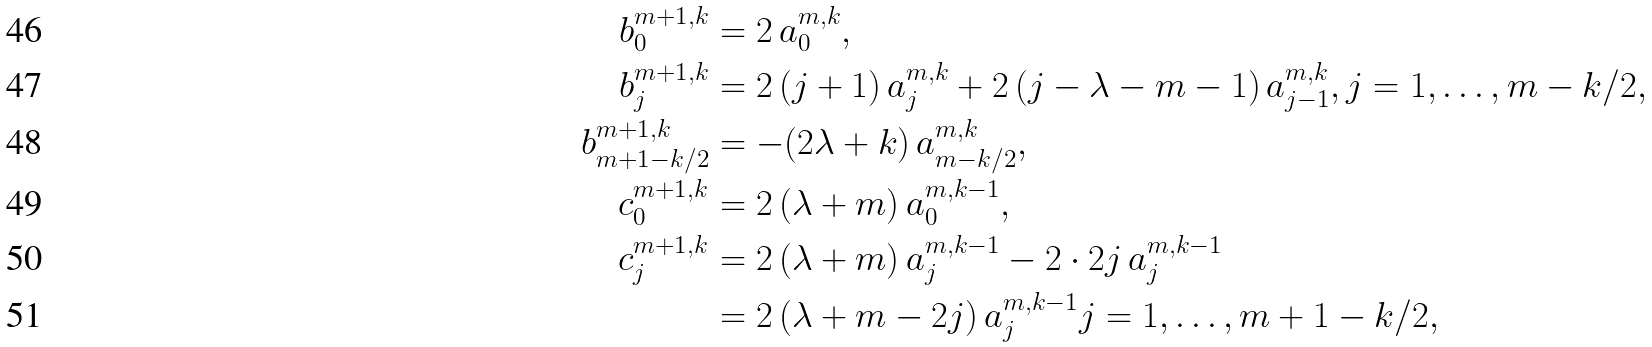<formula> <loc_0><loc_0><loc_500><loc_500>b _ { 0 } ^ { m + 1 , k } & = 2 \, a _ { 0 } ^ { m , k } , \\ b _ { j } ^ { m + 1 , k } & = 2 \, ( j + 1 ) \, a _ { j } ^ { m , k } + 2 \, ( j - \lambda - m - 1 ) \, a _ { j - 1 } ^ { m , k } , j = 1 , \dots , m - k / 2 , \\ b _ { m + 1 - k / 2 } ^ { m + 1 , k } & = - ( 2 \lambda + k ) \, a _ { m - k / 2 } ^ { m , k } , \\ c _ { 0 } ^ { m + 1 , k } & = 2 \, ( \lambda + m ) \, a _ { 0 } ^ { m , k - 1 } , \\ c _ { j } ^ { m + 1 , k } & = 2 \, ( \lambda + m ) \, a _ { j } ^ { m , k - 1 } - 2 \cdot 2 j \, a _ { j } ^ { m , k - 1 } \\ & = 2 \, ( \lambda + m - 2 j ) \, a _ { j } ^ { m , k - 1 } j = 1 , \dots , m + 1 - k / 2 ,</formula> 